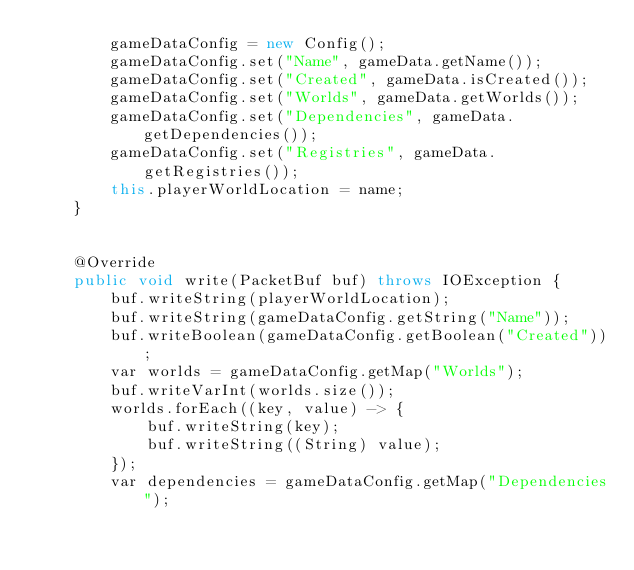Convert code to text. <code><loc_0><loc_0><loc_500><loc_500><_Java_>        gameDataConfig = new Config();
        gameDataConfig.set("Name", gameData.getName());
        gameDataConfig.set("Created", gameData.isCreated());
        gameDataConfig.set("Worlds", gameData.getWorlds());
        gameDataConfig.set("Dependencies", gameData.getDependencies());
        gameDataConfig.set("Registries", gameData.getRegistries());
        this.playerWorldLocation = name;
    }


    @Override
    public void write(PacketBuf buf) throws IOException {
        buf.writeString(playerWorldLocation);
        buf.writeString(gameDataConfig.getString("Name"));
        buf.writeBoolean(gameDataConfig.getBoolean("Created"));
        var worlds = gameDataConfig.getMap("Worlds");
        buf.writeVarInt(worlds.size());
        worlds.forEach((key, value) -> {
            buf.writeString(key);
            buf.writeString((String) value);
        });
        var dependencies = gameDataConfig.getMap("Dependencies");</code> 